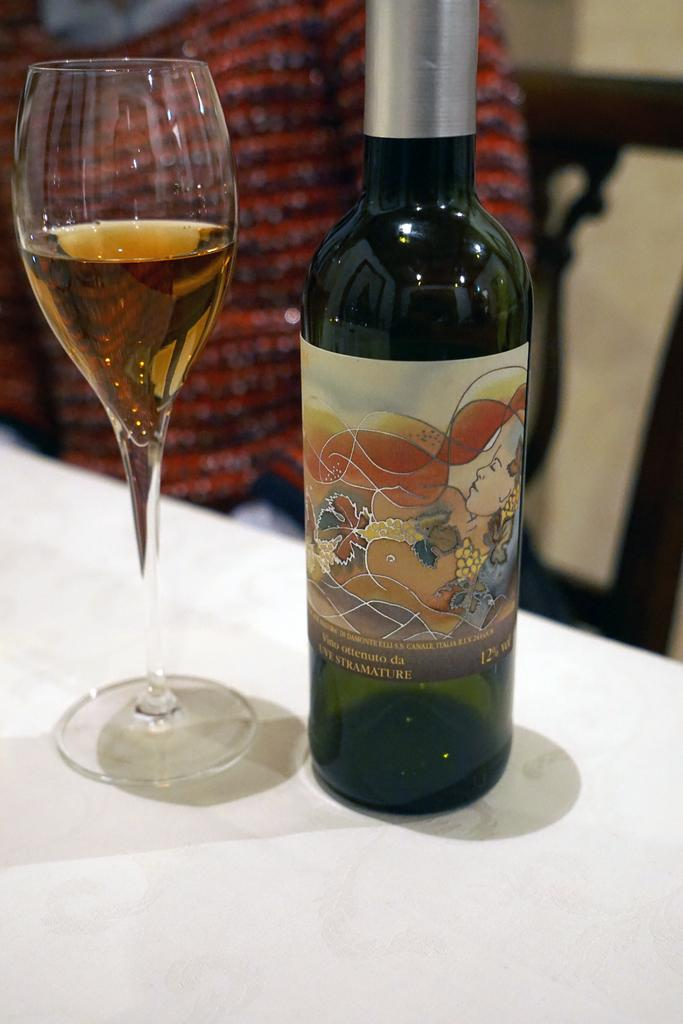What is on the table in the image? There is a bottle and a wine glass on the table. What is the person in the image doing? The person is sitting on a chair behind the table. What type of pest can be seen crawling on the person's chin in the image? There is no pest visible on the person's chin in the image. What type of shade is covering the person in the image? There is no shade covering the person in the image. 